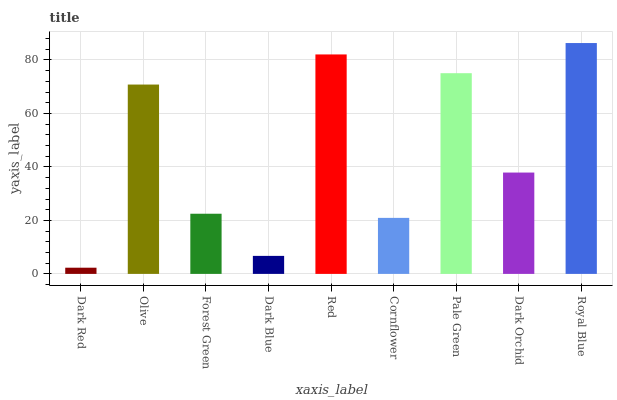Is Dark Red the minimum?
Answer yes or no. Yes. Is Royal Blue the maximum?
Answer yes or no. Yes. Is Olive the minimum?
Answer yes or no. No. Is Olive the maximum?
Answer yes or no. No. Is Olive greater than Dark Red?
Answer yes or no. Yes. Is Dark Red less than Olive?
Answer yes or no. Yes. Is Dark Red greater than Olive?
Answer yes or no. No. Is Olive less than Dark Red?
Answer yes or no. No. Is Dark Orchid the high median?
Answer yes or no. Yes. Is Dark Orchid the low median?
Answer yes or no. Yes. Is Cornflower the high median?
Answer yes or no. No. Is Royal Blue the low median?
Answer yes or no. No. 